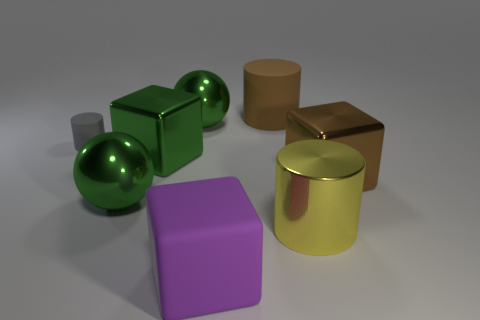Add 2 big blocks. How many objects exist? 10 Subtract all blocks. How many objects are left? 5 Add 8 large rubber things. How many large rubber things exist? 10 Subtract 0 cyan blocks. How many objects are left? 8 Subtract all large green metal blocks. Subtract all large brown cubes. How many objects are left? 6 Add 8 gray rubber cylinders. How many gray rubber cylinders are left? 9 